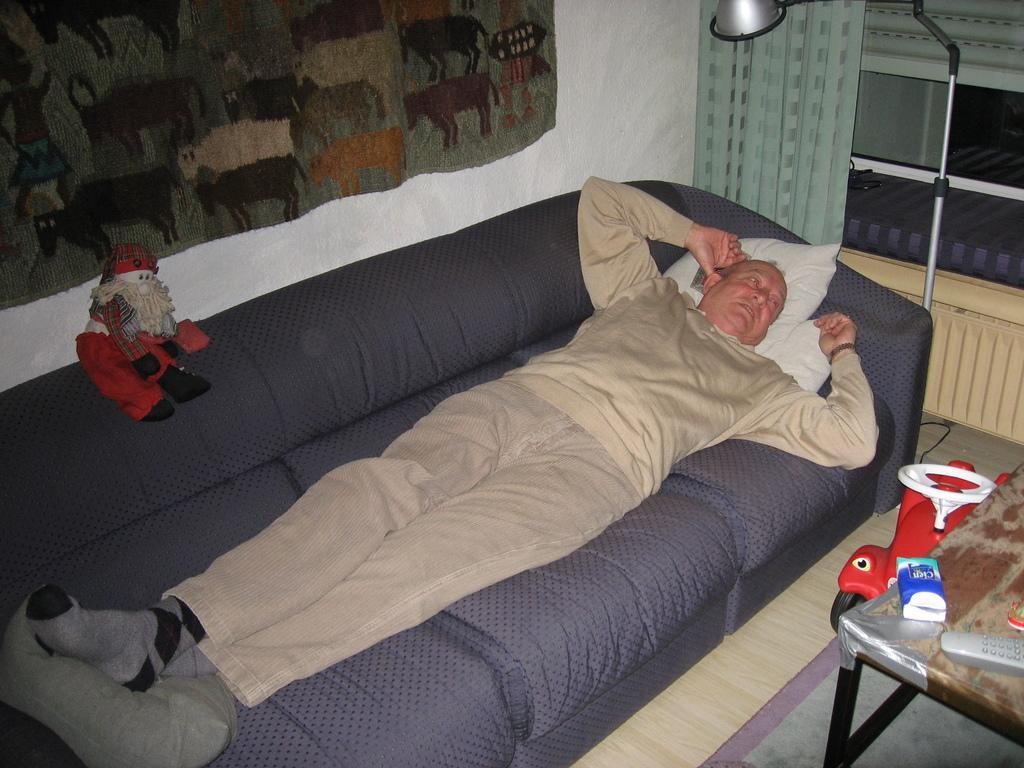Who is present in the image? There is a man in the image. What is the man doing in the image? The man is sleeping on a sofa. What object can be seen providing light in the image? There is a lamp in the image. What piece of furniture is on the right side of the image? There is a table on the right side of the image. What is the condition of the church in the image? There is no church present in the image. What is the man's mother doing in the image? There is no mention of the man's mother in the image. 